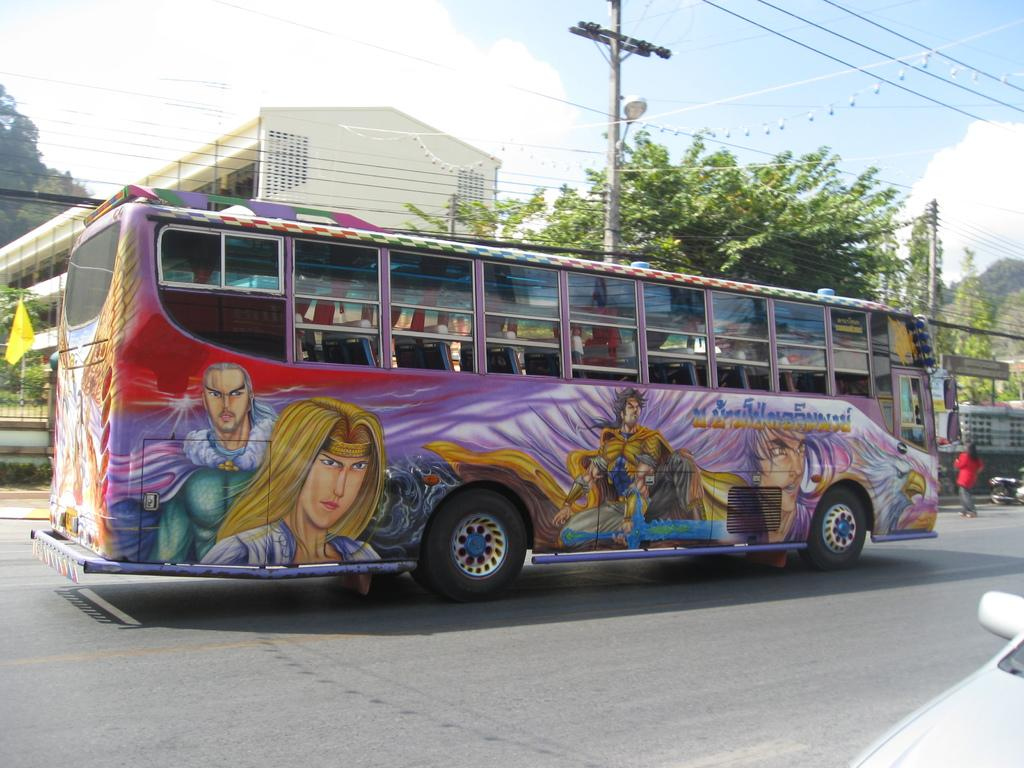What is the main subject of the image? The main subject of the image is a bus. What is unique about the appearance of the bus? The bus has cartoon art on it. What can be seen in the background of the image? There are buildings, trees, and electrical poles in the background of the image. What type of steel is used to construct the space station in the image? There is no space station present in the image, and therefore no steel construction can be observed. 